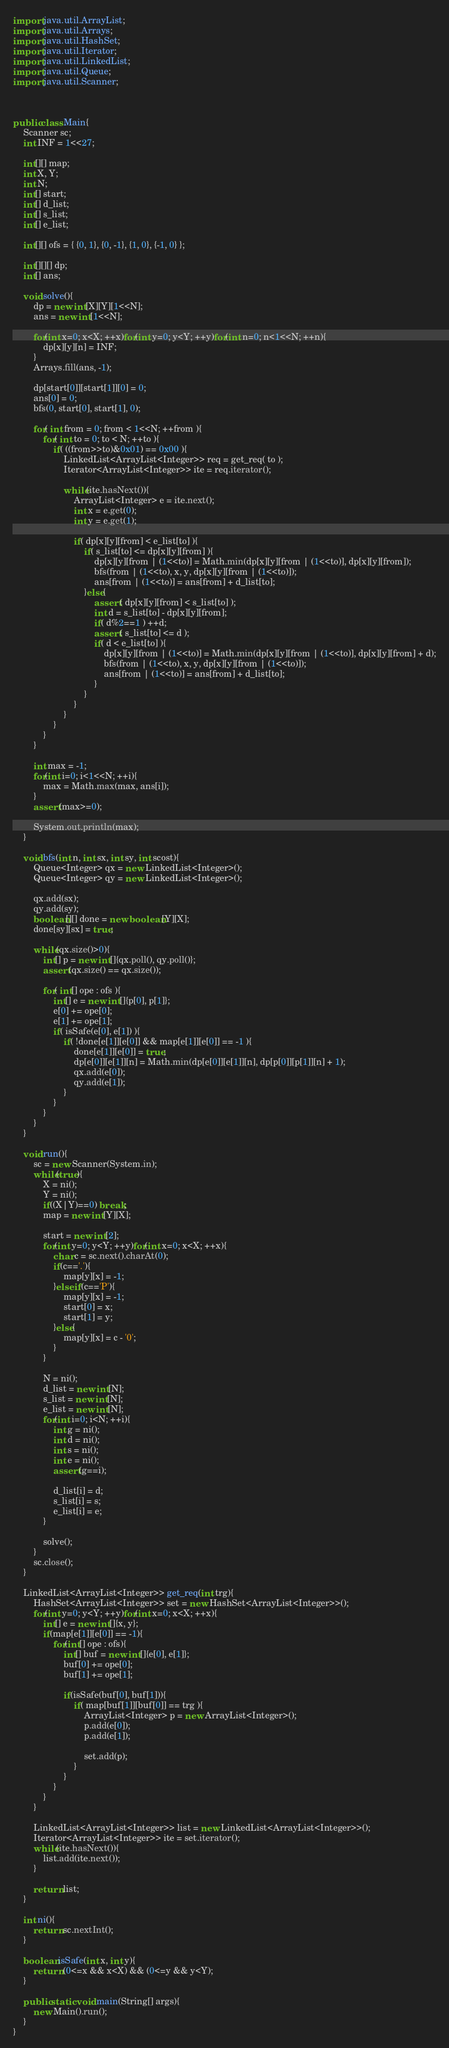<code> <loc_0><loc_0><loc_500><loc_500><_Java_>import java.util.ArrayList;
import java.util.Arrays;
import java.util.HashSet;
import java.util.Iterator;
import java.util.LinkedList;
import java.util.Queue;
import java.util.Scanner;



public class Main{
	Scanner sc;
	int INF = 1<<27;
	
	int[][] map;
	int X, Y;
	int N;
	int[] start;
	int[] d_list;
	int[] s_list;
	int[] e_list;
	
	int[][] ofs = { {0, 1}, {0, -1}, {1, 0}, {-1, 0} };
	
	int[][][] dp;
	int[] ans;
	
	void solve(){
		dp = new int[X][Y][1<<N];
		ans = new int[1<<N];
		
		for(int x=0; x<X; ++x)for(int y=0; y<Y; ++y)for(int n=0; n<1<<N; ++n){
			dp[x][y][n] = INF;
		}
		Arrays.fill(ans, -1);
		
		dp[start[0]][start[1]][0] = 0;
		ans[0] = 0;
		bfs(0, start[0], start[1], 0);
		
		for( int from = 0; from < 1<<N; ++from ){
			for( int to = 0; to < N; ++to ){
				if( ((from>>to)&0x01) == 0x00 ){
					LinkedList<ArrayList<Integer>> req = get_req( to );
					Iterator<ArrayList<Integer>> ite = req.iterator();
					
					while(ite.hasNext()){
						ArrayList<Integer> e = ite.next();
						int x = e.get(0);
						int y = e.get(1);
						
						if( dp[x][y][from] < e_list[to] ){
							if( s_list[to] <= dp[x][y][from] ){
								dp[x][y][from | (1<<to)] = Math.min(dp[x][y][from | (1<<to)], dp[x][y][from]);
								bfs(from | (1<<to), x, y, dp[x][y][from | (1<<to)]);
								ans[from | (1<<to)] = ans[from] + d_list[to];
							}else{
								assert( dp[x][y][from] < s_list[to] );
								int d = s_list[to] - dp[x][y][from];
								if( d%2==1 ) ++d;
								assert( s_list[to] <= d );
								if( d < e_list[to] ){
									dp[x][y][from | (1<<to)] = Math.min(dp[x][y][from | (1<<to)], dp[x][y][from] + d);
									bfs(from | (1<<to), x, y, dp[x][y][from | (1<<to)]);
									ans[from | (1<<to)] = ans[from] + d_list[to];
								}
							}
						}
					}
				}
			}
		}
		
		int max = -1;
		for(int i=0; i<1<<N; ++i){
			max = Math.max(max, ans[i]);
		}
		assert(max>=0);
		
		System.out.println(max);
	}
	
	void bfs(int n, int sx, int sy, int scost){
		Queue<Integer> qx = new LinkedList<Integer>();
		Queue<Integer> qy = new LinkedList<Integer>();
		
		qx.add(sx);
		qy.add(sy);
		boolean[][] done = new boolean[Y][X];
		done[sy][sx] = true;
		
		while(qx.size()>0){
			int[] p = new int[]{qx.poll(), qy.poll()};
			assert(qx.size() == qx.size());
			
			for( int[] ope : ofs ){
				int[] e = new int[]{p[0], p[1]};
				e[0] += ope[0];
				e[1] += ope[1];
				if( isSafe(e[0], e[1]) ){
					if( !done[e[1]][e[0]] && map[e[1]][e[0]] == -1 ){
						done[e[1]][e[0]] = true;
						dp[e[0]][e[1]][n] = Math.min(dp[e[0]][e[1]][n], dp[p[0]][p[1]][n] + 1);
						qx.add(e[0]);
						qy.add(e[1]);
					}
				}
			}
		}
	}
	
	void run(){
		sc = new Scanner(System.in);
		while(true){
			X = ni();
			Y = ni();
			if((X|Y)==0) break;
			map = new int[Y][X];
			
			start = new int[2];
			for(int y=0; y<Y; ++y)for(int x=0; x<X; ++x){
				char c = sc.next().charAt(0);
				if(c=='.'){
					map[y][x] = -1;
				}else if(c=='P'){
					map[y][x] = -1;
					start[0] = x;
					start[1] = y;
				}else{
					map[y][x] = c - '0';
				}
			}
			
			N = ni();
			d_list = new int[N];
			s_list = new int[N];
			e_list = new int[N];
			for(int i=0; i<N; ++i){
				int g = ni();
				int d = ni();
				int s = ni();
				int e = ni();
				assert(g==i);
				
				d_list[i] = d;
				s_list[i] = s;
				e_list[i] = e;
			}
			
			solve();
		}
		sc.close();
	}
	
	LinkedList<ArrayList<Integer>> get_req(int trg){
		HashSet<ArrayList<Integer>> set = new HashSet<ArrayList<Integer>>();
		for(int y=0; y<Y; ++y)for(int x=0; x<X; ++x){
			int[] e = new int[]{x, y};
			if(map[e[1]][e[0]] == -1){
				for(int[] ope : ofs){
					int[] buf = new int[]{e[0], e[1]};
					buf[0] += ope[0];
					buf[1] += ope[1];
					
					if(isSafe(buf[0], buf[1])){
						if( map[buf[1]][buf[0]] == trg ){
							ArrayList<Integer> p = new ArrayList<Integer>();
							p.add(e[0]);
							p.add(e[1]);
							
							set.add(p);
						}
					}
				}
			}
		}
		
		LinkedList<ArrayList<Integer>> list = new LinkedList<ArrayList<Integer>>();
		Iterator<ArrayList<Integer>> ite = set.iterator();
		while(ite.hasNext()){
			list.add(ite.next());
		}
		
		return list;
	}
	
	int ni(){
		return sc.nextInt();
	}
	
	boolean isSafe(int x, int y){
		return (0<=x && x<X) && (0<=y && y<Y);
	}
	
	public static void main(String[] args){
		new Main().run();
	}
}</code> 